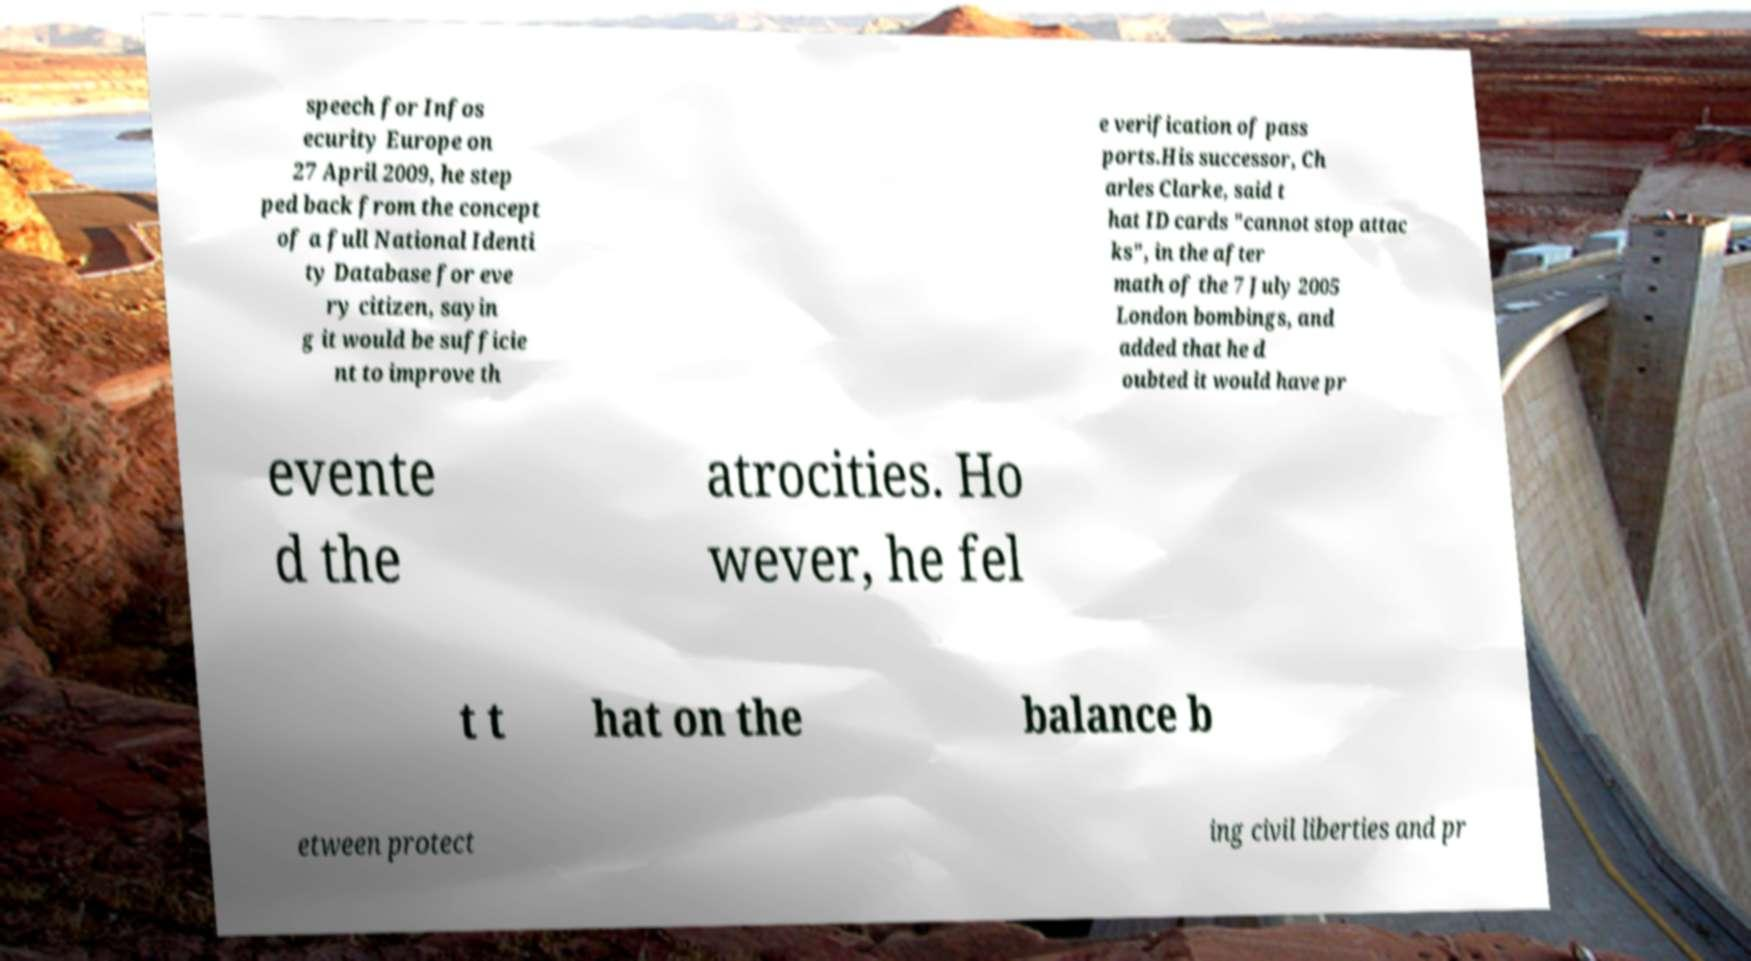Can you read and provide the text displayed in the image?This photo seems to have some interesting text. Can you extract and type it out for me? speech for Infos ecurity Europe on 27 April 2009, he step ped back from the concept of a full National Identi ty Database for eve ry citizen, sayin g it would be sufficie nt to improve th e verification of pass ports.His successor, Ch arles Clarke, said t hat ID cards "cannot stop attac ks", in the after math of the 7 July 2005 London bombings, and added that he d oubted it would have pr evente d the atrocities. Ho wever, he fel t t hat on the balance b etween protect ing civil liberties and pr 